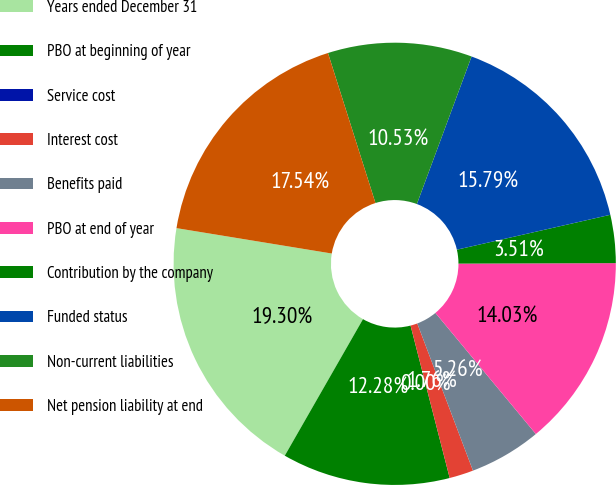Convert chart to OTSL. <chart><loc_0><loc_0><loc_500><loc_500><pie_chart><fcel>Years ended December 31<fcel>PBO at beginning of year<fcel>Service cost<fcel>Interest cost<fcel>Benefits paid<fcel>PBO at end of year<fcel>Contribution by the company<fcel>Funded status<fcel>Non-current liabilities<fcel>Net pension liability at end<nl><fcel>19.3%<fcel>12.28%<fcel>0.0%<fcel>1.76%<fcel>5.26%<fcel>14.03%<fcel>3.51%<fcel>15.79%<fcel>10.53%<fcel>17.54%<nl></chart> 